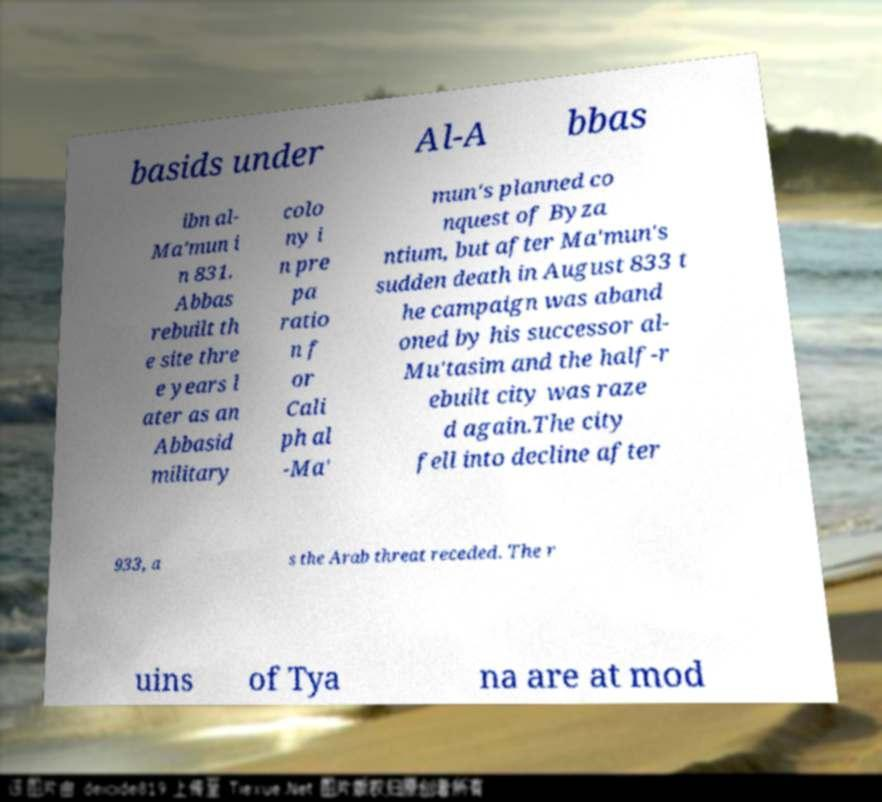I need the written content from this picture converted into text. Can you do that? basids under Al-A bbas ibn al- Ma'mun i n 831. Abbas rebuilt th e site thre e years l ater as an Abbasid military colo ny i n pre pa ratio n f or Cali ph al -Ma' mun's planned co nquest of Byza ntium, but after Ma'mun's sudden death in August 833 t he campaign was aband oned by his successor al- Mu'tasim and the half-r ebuilt city was raze d again.The city fell into decline after 933, a s the Arab threat receded. The r uins of Tya na are at mod 